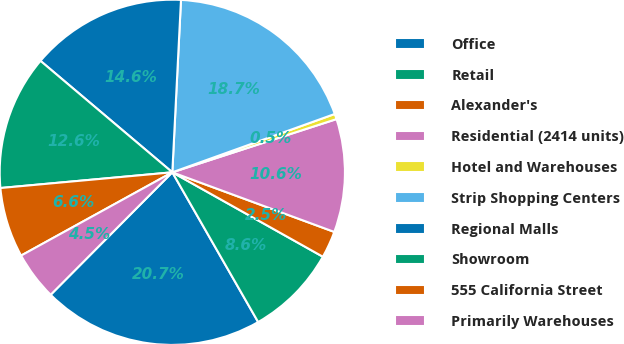Convert chart to OTSL. <chart><loc_0><loc_0><loc_500><loc_500><pie_chart><fcel>Office<fcel>Retail<fcel>Alexander's<fcel>Residential (2414 units)<fcel>Hotel and Warehouses<fcel>Strip Shopping Centers<fcel>Regional Malls<fcel>Showroom<fcel>555 California Street<fcel>Primarily Warehouses<nl><fcel>20.73%<fcel>8.58%<fcel>2.52%<fcel>10.6%<fcel>0.5%<fcel>18.71%<fcel>14.63%<fcel>12.62%<fcel>6.56%<fcel>4.54%<nl></chart> 